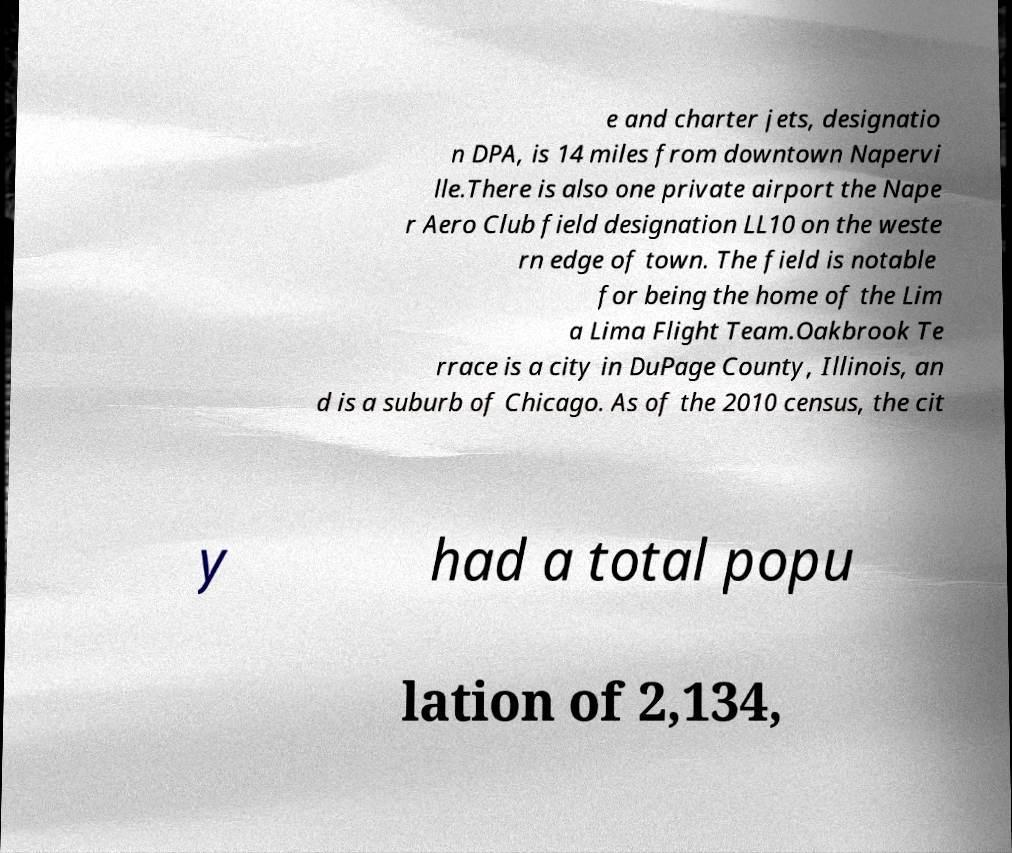Can you read and provide the text displayed in the image?This photo seems to have some interesting text. Can you extract and type it out for me? e and charter jets, designatio n DPA, is 14 miles from downtown Napervi lle.There is also one private airport the Nape r Aero Club field designation LL10 on the weste rn edge of town. The field is notable for being the home of the Lim a Lima Flight Team.Oakbrook Te rrace is a city in DuPage County, Illinois, an d is a suburb of Chicago. As of the 2010 census, the cit y had a total popu lation of 2,134, 